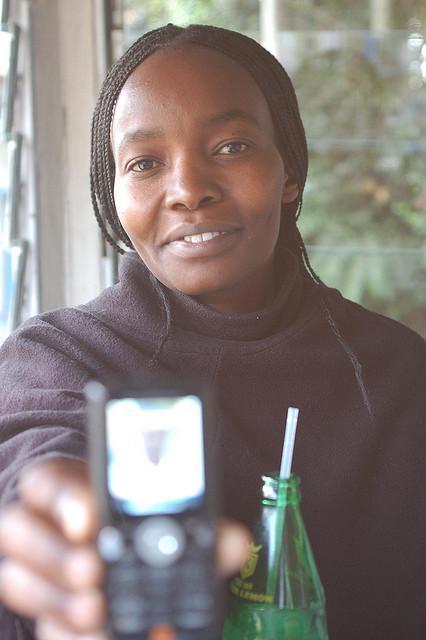How many bottles are in the photo?
Give a very brief answer. 1. 